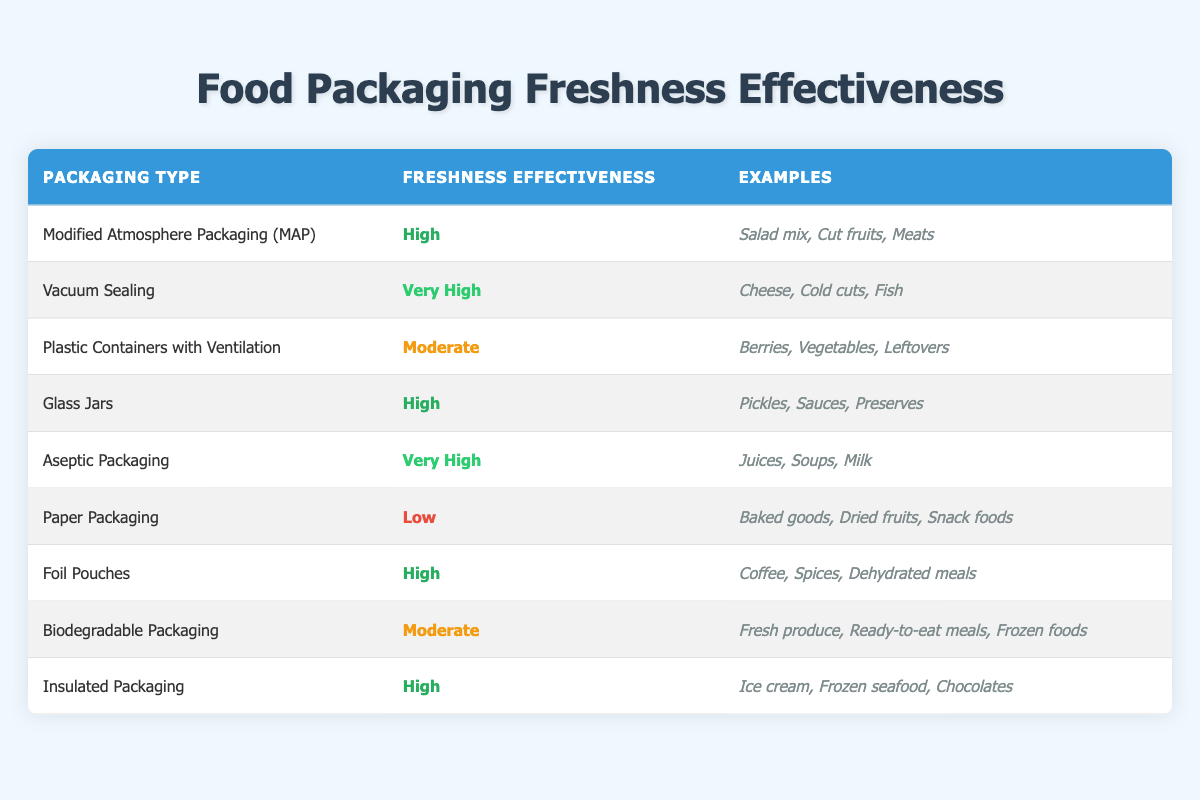What is the freshness effectiveness of Vacuum Sealing? The table indicates that Vacuum Sealing has a freshness effectiveness level of "Very High."
Answer: Very High Which packaging type has a low freshness effectiveness? According to the table, Paper Packaging is listed as having a low freshness effectiveness.
Answer: Paper Packaging How many packaging types have a freshness effectiveness rated as "High"? By examining the table, I see that there are four packaging types marked with "High" effectiveness: Modified Atmosphere Packaging (MAP), Glass Jars, Foil Pouches, and Insulated Packaging.
Answer: 4 Is Glass Jars more effective than Biodegradable Packaging in terms of freshness? The table shows that Glass Jars have a freshness effectiveness of "High," while Biodegradable Packaging has a "Moderate" effectiveness, meaning Glass Jars are more effective.
Answer: Yes What is the average freshness effectiveness of the packaging types? Assigning numerical values to the effectiveness (Very High=4, High=3, Moderate=2, Low=1), we sum their values: (3 + 4 + 2 + 3 + 4 + 1 + 3 + 2 + 3) = 25. Dividing this sum by the number of packaging types (9), we find the average is 25/9, which gives about 2.78, indicating that the average effectiveness is closer to "Moderate."
Answer: Moderate Which packaging type is suitable for storing ice cream? From the table, Insulated Packaging is specifically mentioned as suitable for storing ice cream.
Answer: Insulated Packaging How does Modified Atmosphere Packaging compare to Plastic Containers with Ventilation in terms of freshness effectiveness? The table indicates that Modified Atmosphere Packaging has a "High" freshness effectiveness, while Plastic Containers with Ventilation are rated as "Moderate," making MAP more effective.
Answer: Modified Atmosphere Packaging is more effective What examples are given for Aseptic Packaging? The examples listed in the table for Aseptic Packaging are Juices, Soups, and Milk.
Answer: Juices, Soups, Milk 